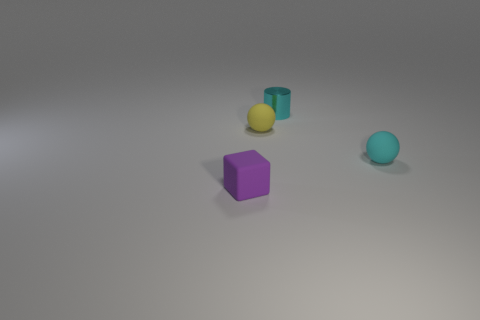Add 1 yellow spheres. How many objects exist? 5 Subtract all small balls. Subtract all cyan things. How many objects are left? 0 Add 2 metallic objects. How many metallic objects are left? 3 Add 4 yellow spheres. How many yellow spheres exist? 5 Subtract 0 green spheres. How many objects are left? 4 Subtract all cylinders. How many objects are left? 3 